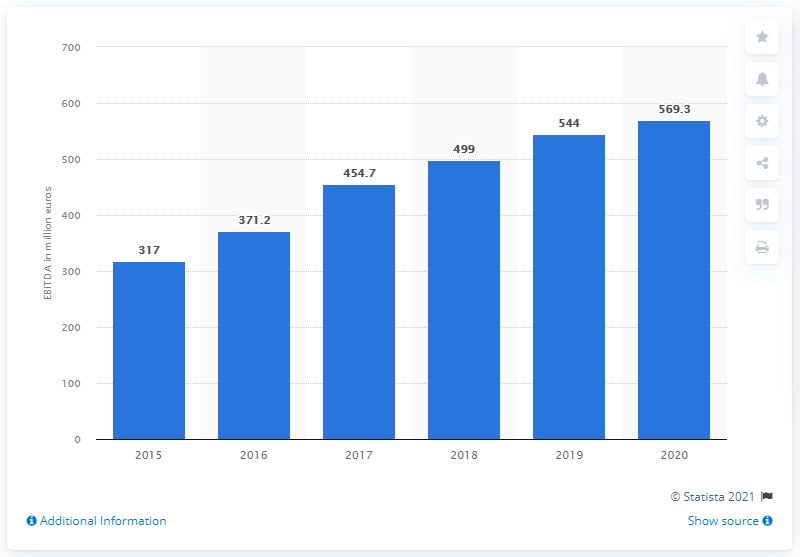List a handful of essential elements in this visual. The EBITDA of Recordati in 2020 was 569.3. 